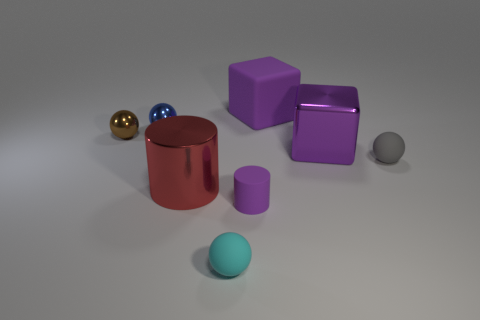Add 1 tiny green rubber balls. How many objects exist? 9 Subtract all cylinders. How many objects are left? 6 Subtract all big purple cylinders. Subtract all small cyan objects. How many objects are left? 7 Add 4 purple cylinders. How many purple cylinders are left? 5 Add 1 brown balls. How many brown balls exist? 2 Subtract 0 cyan cylinders. How many objects are left? 8 